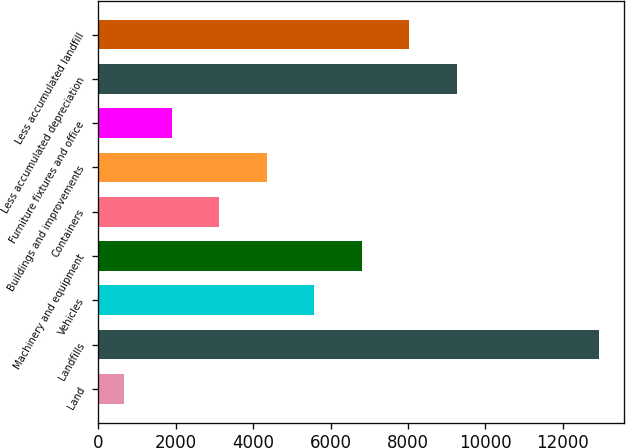Convert chart to OTSL. <chart><loc_0><loc_0><loc_500><loc_500><bar_chart><fcel>Land<fcel>Landfills<fcel>Vehicles<fcel>Machinery and equipment<fcel>Containers<fcel>Buildings and improvements<fcel>Furniture fixtures and office<fcel>Less accumulated depreciation<fcel>Less accumulated landfill<nl><fcel>663<fcel>12940<fcel>5573.8<fcel>6801.5<fcel>3118.4<fcel>4346.1<fcel>1890.7<fcel>9256.9<fcel>8029.2<nl></chart> 